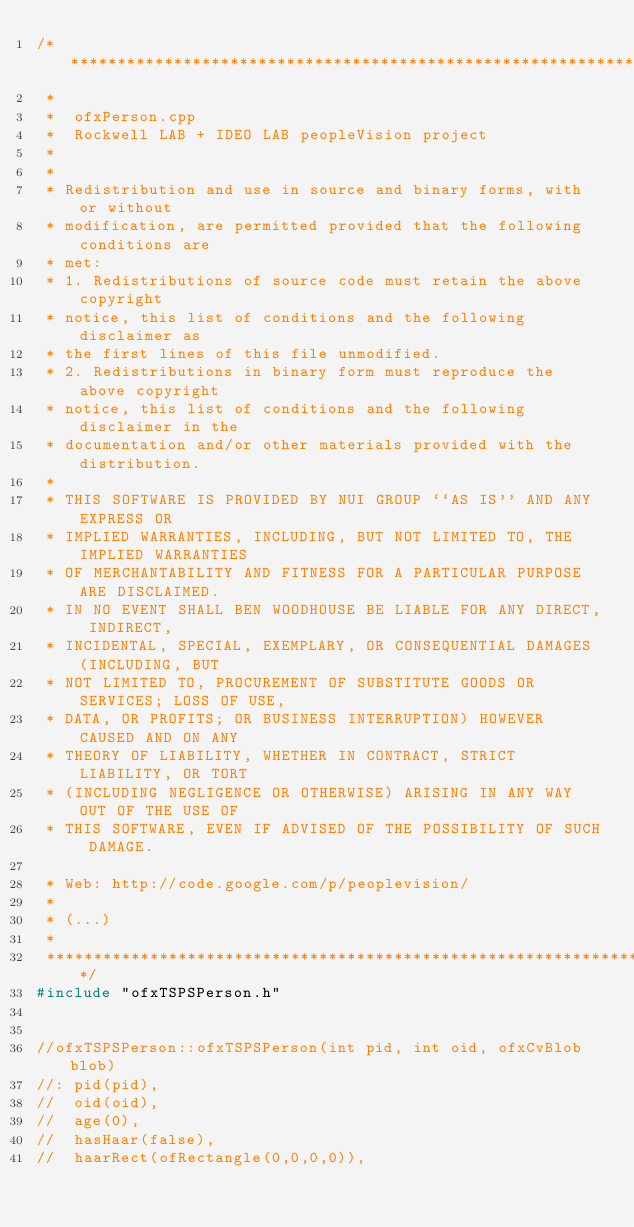<code> <loc_0><loc_0><loc_500><loc_500><_C++_>/***************************************************************************
 *
 *  ofxPerson.cpp
 *  Rockwell LAB + IDEO LAB peopleVision project
 * 
 *
 * Redistribution and use in source and binary forms, with or without
 * modification, are permitted provided that the following conditions are 
 * met:
 * 1. Redistributions of source code must retain the above copyright
 * notice, this list of conditions and the following disclaimer as
 * the first lines of this file unmodified.
 * 2. Redistributions in binary form must reproduce the above copyright
 * notice, this list of conditions and the following disclaimer in the
 * documentation and/or other materials provided with the distribution.
 *
 * THIS SOFTWARE IS PROVIDED BY NUI GROUP ``AS IS'' AND ANY EXPRESS OR
 * IMPLIED WARRANTIES, INCLUDING, BUT NOT LIMITED TO, THE IMPLIED WARRANTIES
 * OF MERCHANTABILITY AND FITNESS FOR A PARTICULAR PURPOSE ARE DISCLAIMED.
 * IN NO EVENT SHALL BEN WOODHOUSE BE LIABLE FOR ANY DIRECT, INDIRECT,
 * INCIDENTAL, SPECIAL, EXEMPLARY, OR CONSEQUENTIAL DAMAGES (INCLUDING, BUT
 * NOT LIMITED TO, PROCUREMENT OF SUBSTITUTE GOODS OR SERVICES; LOSS OF USE,
 * DATA, OR PROFITS; OR BUSINESS INTERRUPTION) HOWEVER CAUSED AND ON ANY
 * THEORY OF LIABILITY, WHETHER IN CONTRACT, STRICT LIABILITY, OR TORT
 * (INCLUDING NEGLIGENCE OR OTHERWISE) ARISING IN ANY WAY OUT OF THE USE OF
 * THIS SOFTWARE, EVEN IF ADVISED OF THE POSSIBILITY OF SUCH DAMAGE.
 
 * Web: http://code.google.com/p/peoplevision/
 *
 * (...)
 *
 ***************************************************************************/
#include "ofxTSPSPerson.h"


//ofxTSPSPerson::ofxTSPSPerson(int pid, int oid, ofxCvBlob blob)
//: pid(pid),
//  oid(oid),
//  age(0),
//  hasHaar(false),
//  haarRect(ofRectangle(0,0,0,0)),</code> 